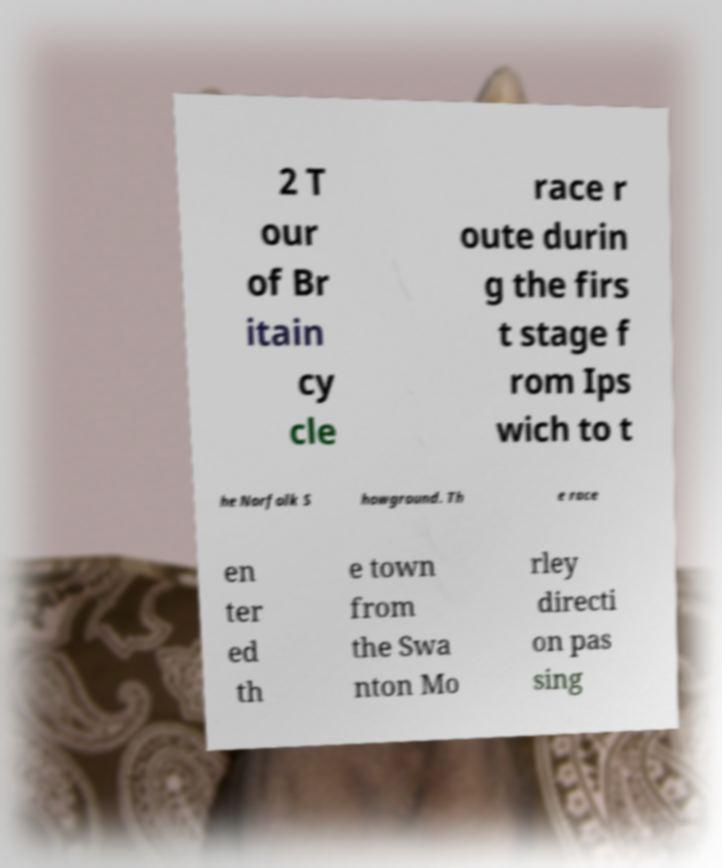There's text embedded in this image that I need extracted. Can you transcribe it verbatim? 2 T our of Br itain cy cle race r oute durin g the firs t stage f rom Ips wich to t he Norfolk S howground. Th e race en ter ed th e town from the Swa nton Mo rley directi on pas sing 